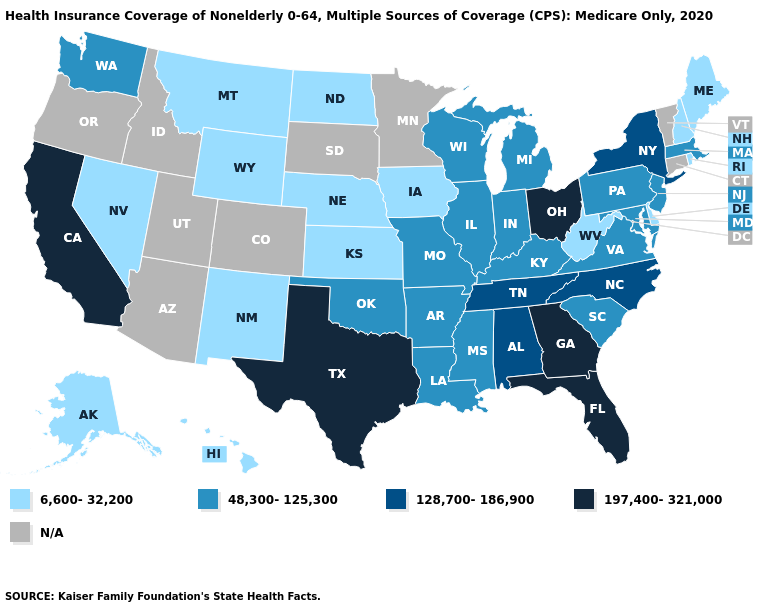What is the value of Texas?
Give a very brief answer. 197,400-321,000. What is the highest value in the MidWest ?
Quick response, please. 197,400-321,000. What is the value of Maine?
Be succinct. 6,600-32,200. What is the value of Connecticut?
Short answer required. N/A. What is the value of West Virginia?
Write a very short answer. 6,600-32,200. What is the value of Louisiana?
Keep it brief. 48,300-125,300. Name the states that have a value in the range 6,600-32,200?
Write a very short answer. Alaska, Delaware, Hawaii, Iowa, Kansas, Maine, Montana, Nebraska, Nevada, New Hampshire, New Mexico, North Dakota, Rhode Island, West Virginia, Wyoming. What is the value of Oklahoma?
Answer briefly. 48,300-125,300. Is the legend a continuous bar?
Quick response, please. No. Among the states that border New Mexico , does Oklahoma have the highest value?
Concise answer only. No. Name the states that have a value in the range 197,400-321,000?
Give a very brief answer. California, Florida, Georgia, Ohio, Texas. Does South Carolina have the highest value in the USA?
Be succinct. No. What is the value of Idaho?
Concise answer only. N/A. 